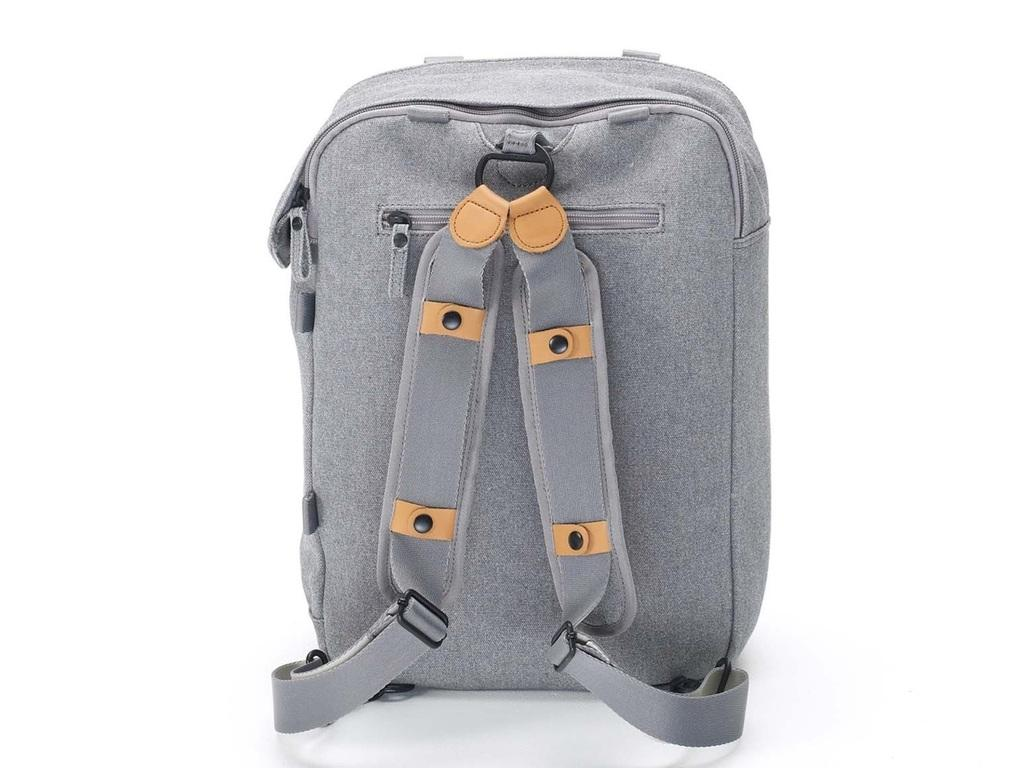What object can be seen in the image? There is a bag in the image. What type of army is depicted in the image? There is no army present in the image; it only features a bag. What is the frame of the image made of? The frame of the image is not visible in the provided facts, so it cannot be determined. 